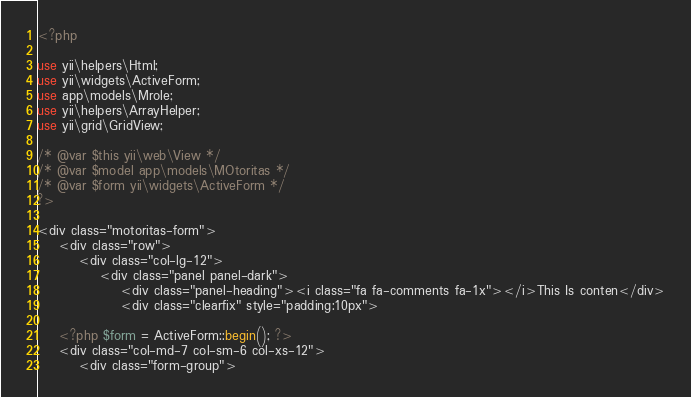Convert code to text. <code><loc_0><loc_0><loc_500><loc_500><_PHP_><?php

use yii\helpers\Html;
use yii\widgets\ActiveForm;
use app\models\Mrole;
use yii\helpers\ArrayHelper;
use yii\grid\GridView;

/* @var $this yii\web\View */
/* @var $model app\models\MOtoritas */
/* @var $form yii\widgets\ActiveForm */
?>

<div class="motoritas-form">
	<div class="row">
        <div class="col-lg-12">
            <div class="panel panel-dark">
                <div class="panel-heading"><i class="fa fa-comments fa-1x"></i>This Is conten</div>
                <div class="clearfix" style="padding:10px">

    <?php $form = ActiveForm::begin(); ?>
    <div class="col-md-7 col-sm-6 col-xs-12">
	    <div class="form-group"></code> 